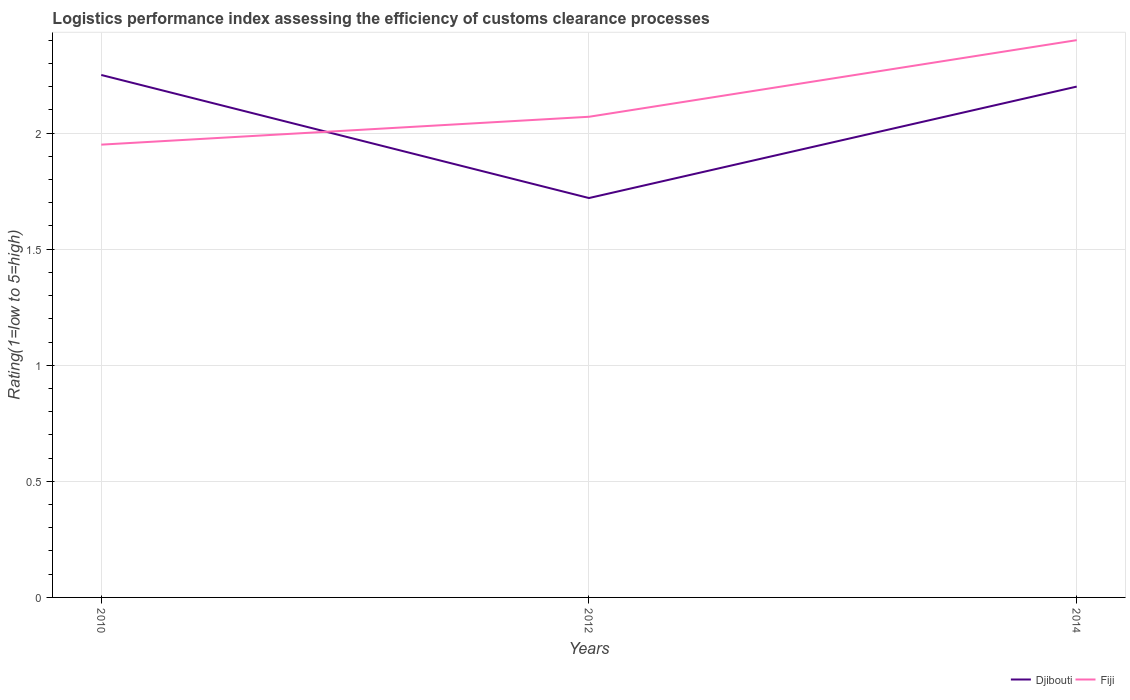Across all years, what is the maximum Logistic performance index in Fiji?
Offer a very short reply. 1.95. In which year was the Logistic performance index in Fiji maximum?
Keep it short and to the point. 2010. What is the total Logistic performance index in Djibouti in the graph?
Ensure brevity in your answer.  -0.48. What is the difference between the highest and the second highest Logistic performance index in Djibouti?
Offer a terse response. 0.53. How many years are there in the graph?
Your answer should be very brief. 3. What is the difference between two consecutive major ticks on the Y-axis?
Your answer should be very brief. 0.5. Are the values on the major ticks of Y-axis written in scientific E-notation?
Your answer should be very brief. No. What is the title of the graph?
Your response must be concise. Logistics performance index assessing the efficiency of customs clearance processes. What is the label or title of the Y-axis?
Offer a terse response. Rating(1=low to 5=high). What is the Rating(1=low to 5=high) in Djibouti in 2010?
Offer a terse response. 2.25. What is the Rating(1=low to 5=high) in Fiji in 2010?
Keep it short and to the point. 1.95. What is the Rating(1=low to 5=high) in Djibouti in 2012?
Provide a short and direct response. 1.72. What is the Rating(1=low to 5=high) of Fiji in 2012?
Provide a succinct answer. 2.07. What is the Rating(1=low to 5=high) in Djibouti in 2014?
Your answer should be very brief. 2.2. What is the Rating(1=low to 5=high) in Fiji in 2014?
Provide a short and direct response. 2.4. Across all years, what is the maximum Rating(1=low to 5=high) of Djibouti?
Offer a very short reply. 2.25. Across all years, what is the maximum Rating(1=low to 5=high) in Fiji?
Make the answer very short. 2.4. Across all years, what is the minimum Rating(1=low to 5=high) of Djibouti?
Give a very brief answer. 1.72. Across all years, what is the minimum Rating(1=low to 5=high) of Fiji?
Keep it short and to the point. 1.95. What is the total Rating(1=low to 5=high) in Djibouti in the graph?
Keep it short and to the point. 6.17. What is the total Rating(1=low to 5=high) of Fiji in the graph?
Offer a very short reply. 6.42. What is the difference between the Rating(1=low to 5=high) in Djibouti in 2010 and that in 2012?
Your answer should be very brief. 0.53. What is the difference between the Rating(1=low to 5=high) in Fiji in 2010 and that in 2012?
Ensure brevity in your answer.  -0.12. What is the difference between the Rating(1=low to 5=high) in Djibouti in 2010 and that in 2014?
Provide a succinct answer. 0.05. What is the difference between the Rating(1=low to 5=high) in Fiji in 2010 and that in 2014?
Make the answer very short. -0.45. What is the difference between the Rating(1=low to 5=high) in Djibouti in 2012 and that in 2014?
Provide a short and direct response. -0.48. What is the difference between the Rating(1=low to 5=high) in Fiji in 2012 and that in 2014?
Make the answer very short. -0.33. What is the difference between the Rating(1=low to 5=high) of Djibouti in 2010 and the Rating(1=low to 5=high) of Fiji in 2012?
Provide a short and direct response. 0.18. What is the difference between the Rating(1=low to 5=high) in Djibouti in 2012 and the Rating(1=low to 5=high) in Fiji in 2014?
Give a very brief answer. -0.68. What is the average Rating(1=low to 5=high) in Djibouti per year?
Keep it short and to the point. 2.06. What is the average Rating(1=low to 5=high) in Fiji per year?
Keep it short and to the point. 2.14. In the year 2010, what is the difference between the Rating(1=low to 5=high) in Djibouti and Rating(1=low to 5=high) in Fiji?
Give a very brief answer. 0.3. In the year 2012, what is the difference between the Rating(1=low to 5=high) of Djibouti and Rating(1=low to 5=high) of Fiji?
Offer a very short reply. -0.35. In the year 2014, what is the difference between the Rating(1=low to 5=high) of Djibouti and Rating(1=low to 5=high) of Fiji?
Provide a short and direct response. -0.2. What is the ratio of the Rating(1=low to 5=high) of Djibouti in 2010 to that in 2012?
Your answer should be compact. 1.31. What is the ratio of the Rating(1=low to 5=high) in Fiji in 2010 to that in 2012?
Ensure brevity in your answer.  0.94. What is the ratio of the Rating(1=low to 5=high) of Djibouti in 2010 to that in 2014?
Offer a very short reply. 1.02. What is the ratio of the Rating(1=low to 5=high) in Fiji in 2010 to that in 2014?
Make the answer very short. 0.81. What is the ratio of the Rating(1=low to 5=high) of Djibouti in 2012 to that in 2014?
Provide a succinct answer. 0.78. What is the ratio of the Rating(1=low to 5=high) of Fiji in 2012 to that in 2014?
Keep it short and to the point. 0.86. What is the difference between the highest and the second highest Rating(1=low to 5=high) of Djibouti?
Keep it short and to the point. 0.05. What is the difference between the highest and the second highest Rating(1=low to 5=high) of Fiji?
Your answer should be compact. 0.33. What is the difference between the highest and the lowest Rating(1=low to 5=high) of Djibouti?
Provide a short and direct response. 0.53. What is the difference between the highest and the lowest Rating(1=low to 5=high) in Fiji?
Make the answer very short. 0.45. 